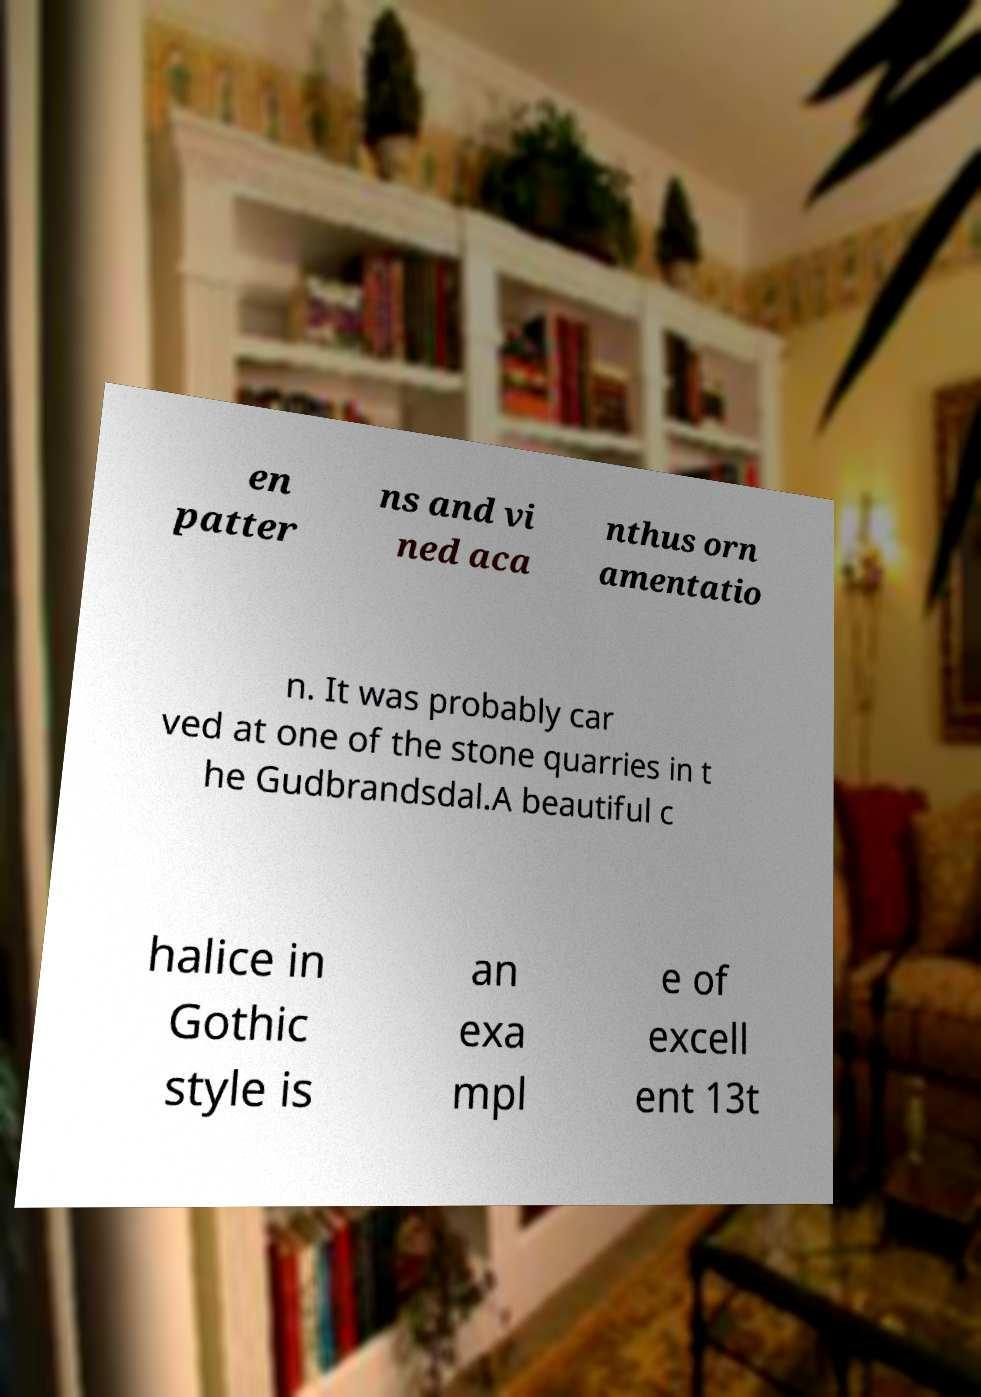There's text embedded in this image that I need extracted. Can you transcribe it verbatim? en patter ns and vi ned aca nthus orn amentatio n. It was probably car ved at one of the stone quarries in t he Gudbrandsdal.A beautiful c halice in Gothic style is an exa mpl e of excell ent 13t 